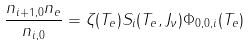<formula> <loc_0><loc_0><loc_500><loc_500>\frac { n _ { i + 1 , 0 } n _ { e } } { n _ { i , 0 } } = \zeta ( T _ { e } ) S _ { i } ( T _ { e } , J _ { \nu } ) \Phi _ { 0 , 0 , i } ( T _ { e } )</formula> 